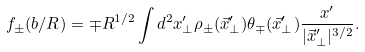Convert formula to latex. <formula><loc_0><loc_0><loc_500><loc_500>f _ { \pm } ( b / R ) = \mp R ^ { 1 / 2 } \int d ^ { 2 } x _ { \perp } ^ { \prime } \rho _ { \pm } ( \vec { x } _ { \perp } ^ { \prime } ) \theta _ { \mp } ( \vec { x } _ { \perp } ^ { \prime } ) \frac { x ^ { \prime } } { | \vec { x } ^ { \prime } _ { \perp } | ^ { 3 / 2 } } .</formula> 